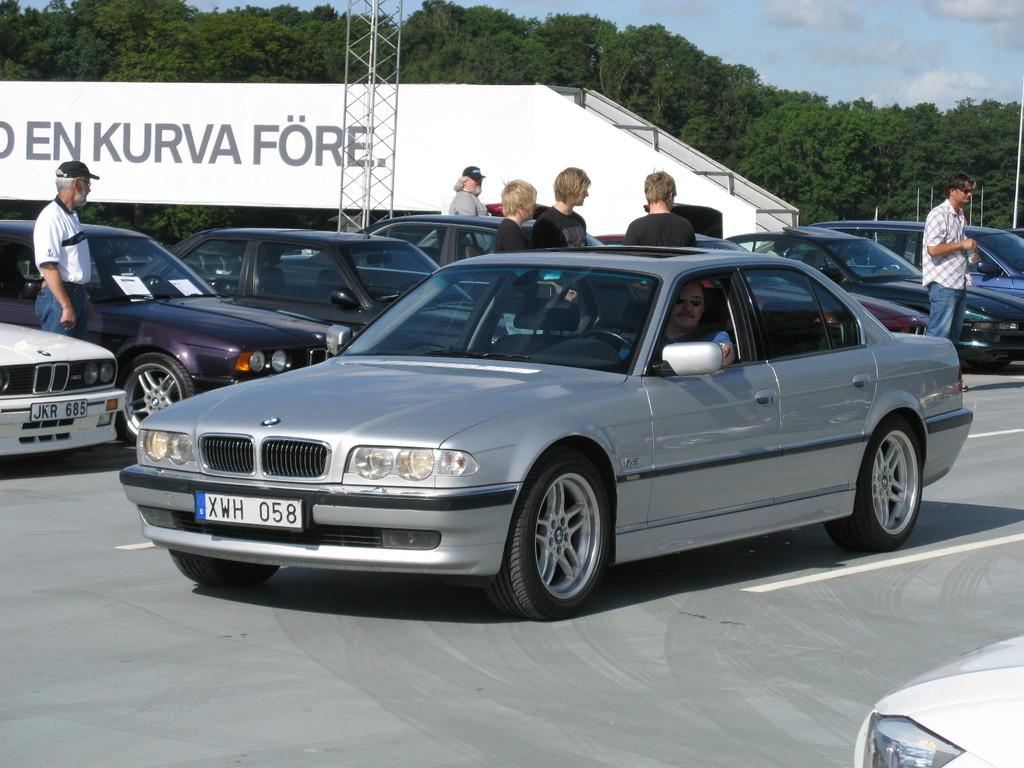What type of vehicles can be seen in the image? There are cars in the image. What are the people on the road doing? The people standing on the road are visible in the image. What can be seen in the background of the image? There are trees in the background of the image. What is written on the wall in the image? There is a wall with some text in the image. What is visible in the sky in the image? The sky is visible in the image, and clouds are present. What type of bird can be seen taking a voyage in the image? There is no bird present in the image, and therefore no such activity can be observed. What answer is written on the wall in the image? The wall in the image has some text, but it is not an answer to a question. 